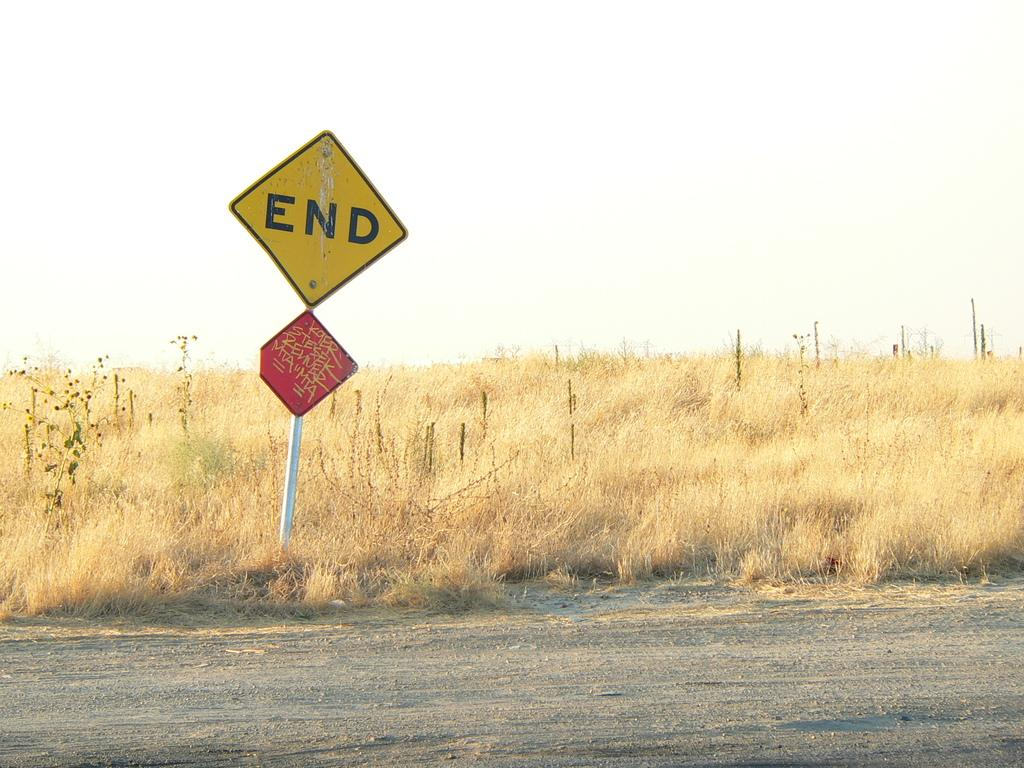<image>
Create a compact narrative representing the image presented. a yellow sign that says end on it 